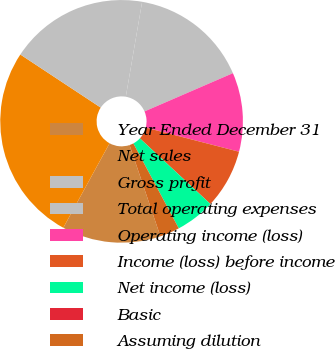Convert chart. <chart><loc_0><loc_0><loc_500><loc_500><pie_chart><fcel>Year Ended December 31<fcel>Net sales<fcel>Gross profit<fcel>Total operating expenses<fcel>Operating income (loss)<fcel>Income (loss) before income<fcel>Net income (loss)<fcel>Basic<fcel>Assuming dilution<nl><fcel>13.16%<fcel>26.31%<fcel>18.42%<fcel>15.79%<fcel>10.53%<fcel>7.9%<fcel>5.26%<fcel>0.0%<fcel>2.63%<nl></chart> 